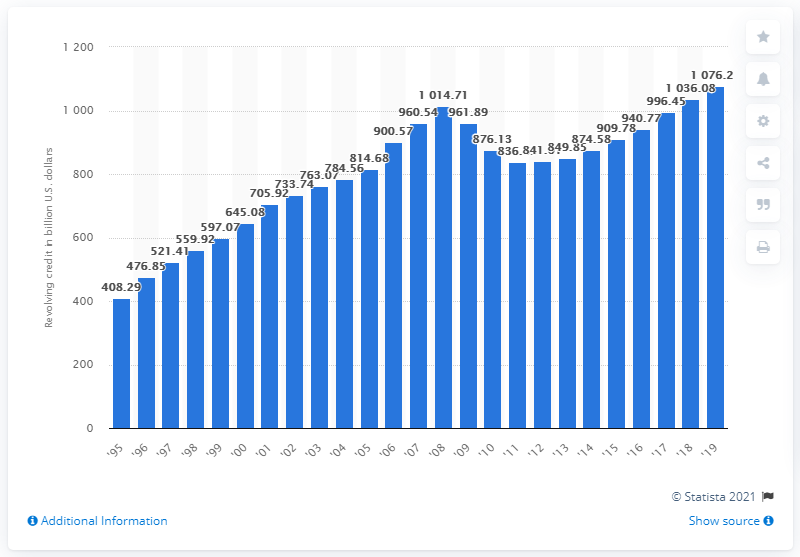Highlight a few significant elements in this photo. In 2019, the outstanding revolving credit in the United States was approximately 1076.27 billion dollars. 